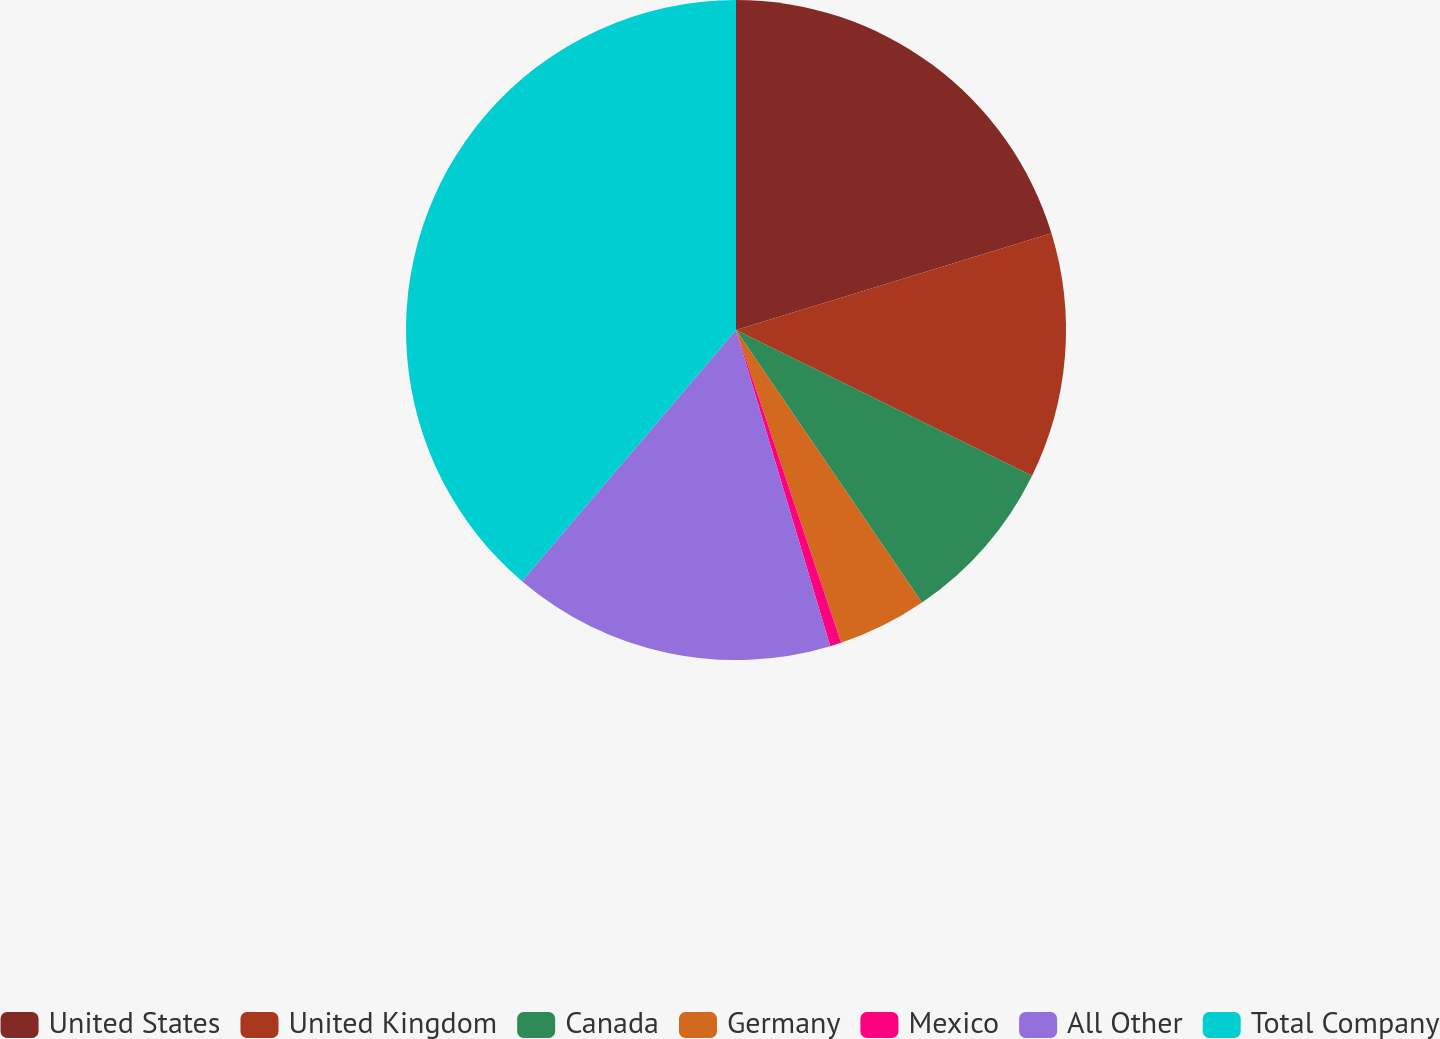Convert chart to OTSL. <chart><loc_0><loc_0><loc_500><loc_500><pie_chart><fcel>United States<fcel>United Kingdom<fcel>Canada<fcel>Germany<fcel>Mexico<fcel>All Other<fcel>Total Company<nl><fcel>20.26%<fcel>12.02%<fcel>8.19%<fcel>4.37%<fcel>0.55%<fcel>15.84%<fcel>38.77%<nl></chart> 